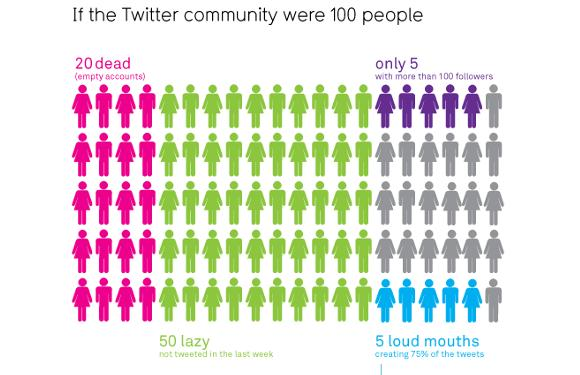Identify some key points in this picture. Pink was previously used to represent an empty account. The color represented by the value lazy-pink is violet. The color represented by the value green is green. The color represented by the value blue is blue. 